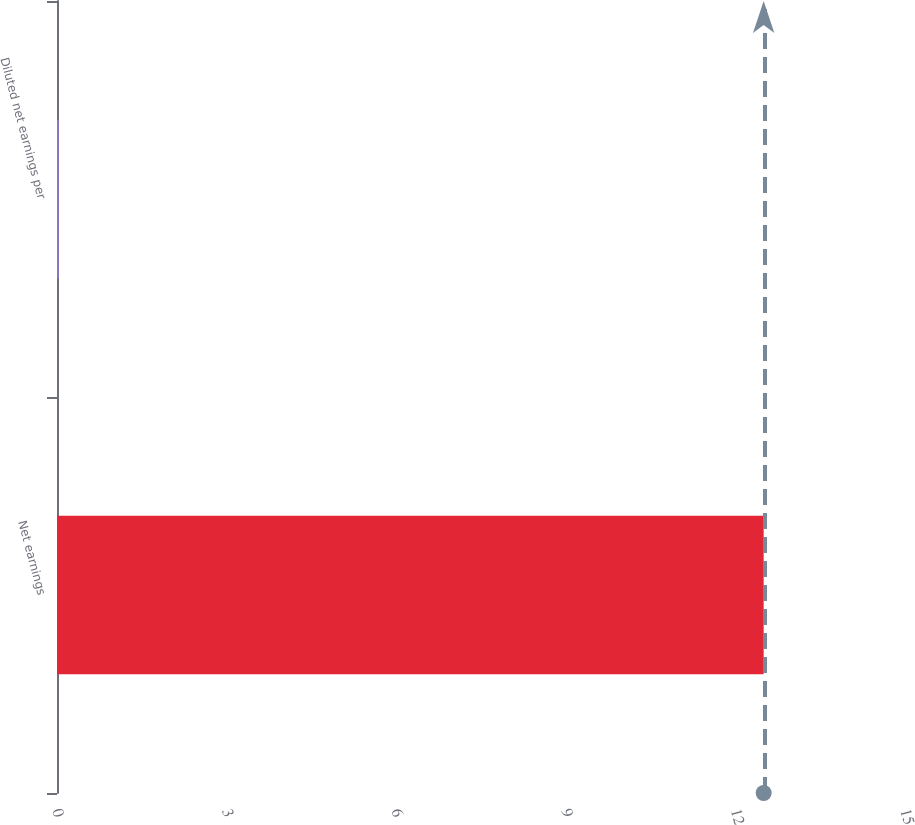Convert chart. <chart><loc_0><loc_0><loc_500><loc_500><bar_chart><fcel>Net earnings<fcel>Diluted net earnings per<nl><fcel>12.5<fcel>0.03<nl></chart> 